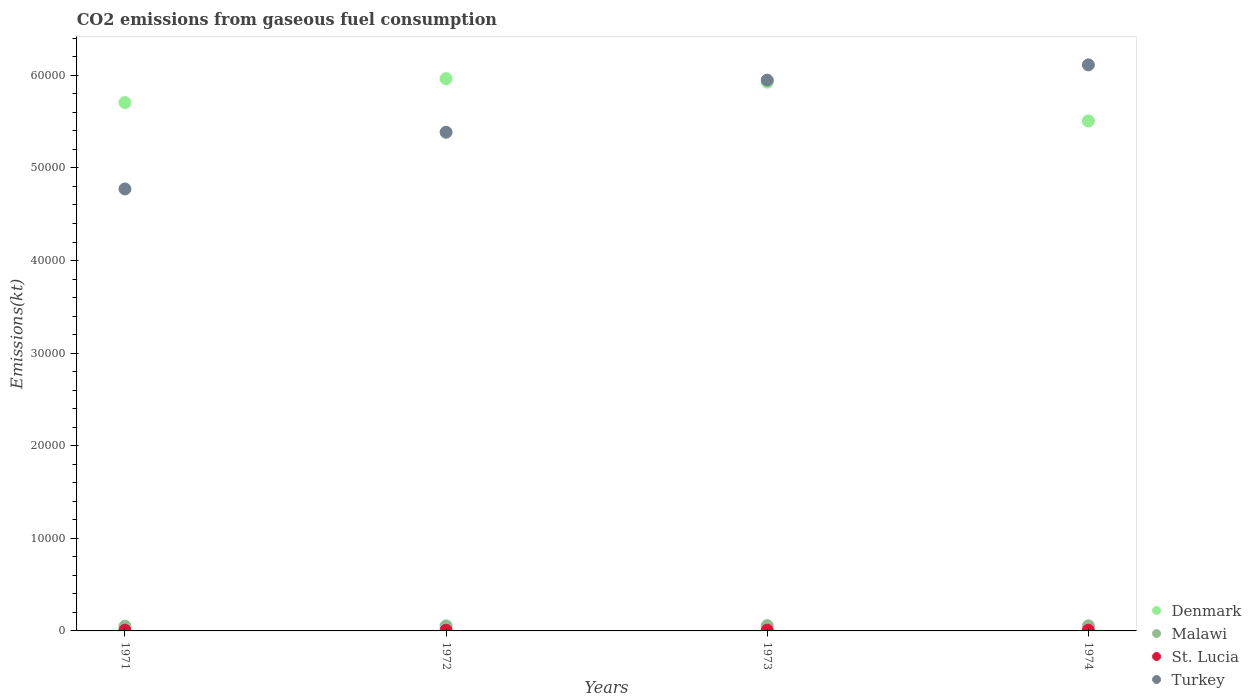What is the amount of CO2 emitted in Denmark in 1971?
Make the answer very short. 5.71e+04. Across all years, what is the maximum amount of CO2 emitted in Denmark?
Keep it short and to the point. 5.96e+04. Across all years, what is the minimum amount of CO2 emitted in Turkey?
Offer a terse response. 4.77e+04. In which year was the amount of CO2 emitted in St. Lucia maximum?
Keep it short and to the point. 1973. What is the total amount of CO2 emitted in Malawi in the graph?
Keep it short and to the point. 2170.86. What is the difference between the amount of CO2 emitted in Malawi in 1971 and that in 1974?
Provide a short and direct response. -47.67. What is the difference between the amount of CO2 emitted in Malawi in 1972 and the amount of CO2 emitted in Denmark in 1974?
Provide a short and direct response. -5.45e+04. What is the average amount of CO2 emitted in St. Lucia per year?
Your response must be concise. 75.17. In the year 1973, what is the difference between the amount of CO2 emitted in St. Lucia and amount of CO2 emitted in Malawi?
Give a very brief answer. -491.38. What is the ratio of the amount of CO2 emitted in Turkey in 1971 to that in 1974?
Ensure brevity in your answer.  0.78. What is the difference between the highest and the second highest amount of CO2 emitted in Denmark?
Offer a terse response. 377.7. What is the difference between the highest and the lowest amount of CO2 emitted in Malawi?
Your response must be concise. 69.67. In how many years, is the amount of CO2 emitted in Malawi greater than the average amount of CO2 emitted in Malawi taken over all years?
Offer a terse response. 3. Are the values on the major ticks of Y-axis written in scientific E-notation?
Provide a succinct answer. No. Does the graph contain grids?
Your answer should be compact. No. What is the title of the graph?
Give a very brief answer. CO2 emissions from gaseous fuel consumption. Does "Belize" appear as one of the legend labels in the graph?
Ensure brevity in your answer.  No. What is the label or title of the Y-axis?
Provide a short and direct response. Emissions(kt). What is the Emissions(kt) of Denmark in 1971?
Your answer should be compact. 5.71e+04. What is the Emissions(kt) of Malawi in 1971?
Provide a short and direct response. 502.38. What is the Emissions(kt) of St. Lucia in 1971?
Keep it short and to the point. 69.67. What is the Emissions(kt) of Turkey in 1971?
Your answer should be compact. 4.77e+04. What is the Emissions(kt) in Denmark in 1972?
Make the answer very short. 5.96e+04. What is the Emissions(kt) in Malawi in 1972?
Keep it short and to the point. 546.38. What is the Emissions(kt) in St. Lucia in 1972?
Your answer should be compact. 77.01. What is the Emissions(kt) in Turkey in 1972?
Make the answer very short. 5.39e+04. What is the Emissions(kt) in Denmark in 1973?
Provide a short and direct response. 5.93e+04. What is the Emissions(kt) of Malawi in 1973?
Offer a terse response. 572.05. What is the Emissions(kt) of St. Lucia in 1973?
Ensure brevity in your answer.  80.67. What is the Emissions(kt) in Turkey in 1973?
Provide a succinct answer. 5.95e+04. What is the Emissions(kt) of Denmark in 1974?
Ensure brevity in your answer.  5.51e+04. What is the Emissions(kt) in Malawi in 1974?
Provide a succinct answer. 550.05. What is the Emissions(kt) in St. Lucia in 1974?
Make the answer very short. 73.34. What is the Emissions(kt) of Turkey in 1974?
Provide a succinct answer. 6.11e+04. Across all years, what is the maximum Emissions(kt) of Denmark?
Provide a succinct answer. 5.96e+04. Across all years, what is the maximum Emissions(kt) in Malawi?
Your answer should be compact. 572.05. Across all years, what is the maximum Emissions(kt) of St. Lucia?
Offer a very short reply. 80.67. Across all years, what is the maximum Emissions(kt) of Turkey?
Keep it short and to the point. 6.11e+04. Across all years, what is the minimum Emissions(kt) of Denmark?
Ensure brevity in your answer.  5.51e+04. Across all years, what is the minimum Emissions(kt) in Malawi?
Your response must be concise. 502.38. Across all years, what is the minimum Emissions(kt) of St. Lucia?
Your response must be concise. 69.67. Across all years, what is the minimum Emissions(kt) of Turkey?
Provide a short and direct response. 4.77e+04. What is the total Emissions(kt) in Denmark in the graph?
Your answer should be compact. 2.31e+05. What is the total Emissions(kt) in Malawi in the graph?
Provide a short and direct response. 2170.86. What is the total Emissions(kt) of St. Lucia in the graph?
Provide a short and direct response. 300.69. What is the total Emissions(kt) of Turkey in the graph?
Offer a terse response. 2.22e+05. What is the difference between the Emissions(kt) of Denmark in 1971 and that in 1972?
Your response must be concise. -2581.57. What is the difference between the Emissions(kt) in Malawi in 1971 and that in 1972?
Your response must be concise. -44. What is the difference between the Emissions(kt) in St. Lucia in 1971 and that in 1972?
Your response must be concise. -7.33. What is the difference between the Emissions(kt) in Turkey in 1971 and that in 1972?
Offer a very short reply. -6123.89. What is the difference between the Emissions(kt) of Denmark in 1971 and that in 1973?
Provide a short and direct response. -2203.87. What is the difference between the Emissions(kt) of Malawi in 1971 and that in 1973?
Your answer should be compact. -69.67. What is the difference between the Emissions(kt) in St. Lucia in 1971 and that in 1973?
Your answer should be compact. -11. What is the difference between the Emissions(kt) of Turkey in 1971 and that in 1973?
Provide a succinct answer. -1.18e+04. What is the difference between the Emissions(kt) in Denmark in 1971 and that in 1974?
Your response must be concise. 1983.85. What is the difference between the Emissions(kt) in Malawi in 1971 and that in 1974?
Your answer should be compact. -47.67. What is the difference between the Emissions(kt) of St. Lucia in 1971 and that in 1974?
Keep it short and to the point. -3.67. What is the difference between the Emissions(kt) in Turkey in 1971 and that in 1974?
Provide a short and direct response. -1.34e+04. What is the difference between the Emissions(kt) in Denmark in 1972 and that in 1973?
Provide a short and direct response. 377.7. What is the difference between the Emissions(kt) in Malawi in 1972 and that in 1973?
Give a very brief answer. -25.67. What is the difference between the Emissions(kt) of St. Lucia in 1972 and that in 1973?
Ensure brevity in your answer.  -3.67. What is the difference between the Emissions(kt) in Turkey in 1972 and that in 1973?
Offer a very short reply. -5628.85. What is the difference between the Emissions(kt) of Denmark in 1972 and that in 1974?
Offer a very short reply. 4565.41. What is the difference between the Emissions(kt) of Malawi in 1972 and that in 1974?
Provide a succinct answer. -3.67. What is the difference between the Emissions(kt) of St. Lucia in 1972 and that in 1974?
Make the answer very short. 3.67. What is the difference between the Emissions(kt) of Turkey in 1972 and that in 1974?
Your answer should be very brief. -7278.99. What is the difference between the Emissions(kt) in Denmark in 1973 and that in 1974?
Offer a very short reply. 4187.71. What is the difference between the Emissions(kt) in Malawi in 1973 and that in 1974?
Your answer should be compact. 22. What is the difference between the Emissions(kt) of St. Lucia in 1973 and that in 1974?
Offer a very short reply. 7.33. What is the difference between the Emissions(kt) of Turkey in 1973 and that in 1974?
Keep it short and to the point. -1650.15. What is the difference between the Emissions(kt) of Denmark in 1971 and the Emissions(kt) of Malawi in 1972?
Keep it short and to the point. 5.65e+04. What is the difference between the Emissions(kt) in Denmark in 1971 and the Emissions(kt) in St. Lucia in 1972?
Provide a succinct answer. 5.70e+04. What is the difference between the Emissions(kt) of Denmark in 1971 and the Emissions(kt) of Turkey in 1972?
Offer a very short reply. 3204.96. What is the difference between the Emissions(kt) of Malawi in 1971 and the Emissions(kt) of St. Lucia in 1972?
Keep it short and to the point. 425.37. What is the difference between the Emissions(kt) of Malawi in 1971 and the Emissions(kt) of Turkey in 1972?
Offer a terse response. -5.34e+04. What is the difference between the Emissions(kt) of St. Lucia in 1971 and the Emissions(kt) of Turkey in 1972?
Your answer should be compact. -5.38e+04. What is the difference between the Emissions(kt) in Denmark in 1971 and the Emissions(kt) in Malawi in 1973?
Give a very brief answer. 5.65e+04. What is the difference between the Emissions(kt) of Denmark in 1971 and the Emissions(kt) of St. Lucia in 1973?
Make the answer very short. 5.70e+04. What is the difference between the Emissions(kt) in Denmark in 1971 and the Emissions(kt) in Turkey in 1973?
Your answer should be compact. -2423.89. What is the difference between the Emissions(kt) in Malawi in 1971 and the Emissions(kt) in St. Lucia in 1973?
Ensure brevity in your answer.  421.7. What is the difference between the Emissions(kt) in Malawi in 1971 and the Emissions(kt) in Turkey in 1973?
Your response must be concise. -5.90e+04. What is the difference between the Emissions(kt) in St. Lucia in 1971 and the Emissions(kt) in Turkey in 1973?
Keep it short and to the point. -5.94e+04. What is the difference between the Emissions(kt) of Denmark in 1971 and the Emissions(kt) of Malawi in 1974?
Provide a succinct answer. 5.65e+04. What is the difference between the Emissions(kt) of Denmark in 1971 and the Emissions(kt) of St. Lucia in 1974?
Provide a short and direct response. 5.70e+04. What is the difference between the Emissions(kt) of Denmark in 1971 and the Emissions(kt) of Turkey in 1974?
Ensure brevity in your answer.  -4074.04. What is the difference between the Emissions(kt) of Malawi in 1971 and the Emissions(kt) of St. Lucia in 1974?
Give a very brief answer. 429.04. What is the difference between the Emissions(kt) of Malawi in 1971 and the Emissions(kt) of Turkey in 1974?
Provide a succinct answer. -6.06e+04. What is the difference between the Emissions(kt) in St. Lucia in 1971 and the Emissions(kt) in Turkey in 1974?
Ensure brevity in your answer.  -6.11e+04. What is the difference between the Emissions(kt) of Denmark in 1972 and the Emissions(kt) of Malawi in 1973?
Provide a succinct answer. 5.91e+04. What is the difference between the Emissions(kt) of Denmark in 1972 and the Emissions(kt) of St. Lucia in 1973?
Your response must be concise. 5.96e+04. What is the difference between the Emissions(kt) of Denmark in 1972 and the Emissions(kt) of Turkey in 1973?
Your answer should be compact. 157.68. What is the difference between the Emissions(kt) of Malawi in 1972 and the Emissions(kt) of St. Lucia in 1973?
Provide a short and direct response. 465.71. What is the difference between the Emissions(kt) in Malawi in 1972 and the Emissions(kt) in Turkey in 1973?
Keep it short and to the point. -5.89e+04. What is the difference between the Emissions(kt) of St. Lucia in 1972 and the Emissions(kt) of Turkey in 1973?
Provide a short and direct response. -5.94e+04. What is the difference between the Emissions(kt) in Denmark in 1972 and the Emissions(kt) in Malawi in 1974?
Provide a short and direct response. 5.91e+04. What is the difference between the Emissions(kt) of Denmark in 1972 and the Emissions(kt) of St. Lucia in 1974?
Your response must be concise. 5.96e+04. What is the difference between the Emissions(kt) in Denmark in 1972 and the Emissions(kt) in Turkey in 1974?
Keep it short and to the point. -1492.47. What is the difference between the Emissions(kt) of Malawi in 1972 and the Emissions(kt) of St. Lucia in 1974?
Keep it short and to the point. 473.04. What is the difference between the Emissions(kt) in Malawi in 1972 and the Emissions(kt) in Turkey in 1974?
Ensure brevity in your answer.  -6.06e+04. What is the difference between the Emissions(kt) of St. Lucia in 1972 and the Emissions(kt) of Turkey in 1974?
Your response must be concise. -6.11e+04. What is the difference between the Emissions(kt) of Denmark in 1973 and the Emissions(kt) of Malawi in 1974?
Keep it short and to the point. 5.87e+04. What is the difference between the Emissions(kt) in Denmark in 1973 and the Emissions(kt) in St. Lucia in 1974?
Your answer should be very brief. 5.92e+04. What is the difference between the Emissions(kt) in Denmark in 1973 and the Emissions(kt) in Turkey in 1974?
Ensure brevity in your answer.  -1870.17. What is the difference between the Emissions(kt) in Malawi in 1973 and the Emissions(kt) in St. Lucia in 1974?
Give a very brief answer. 498.71. What is the difference between the Emissions(kt) in Malawi in 1973 and the Emissions(kt) in Turkey in 1974?
Make the answer very short. -6.06e+04. What is the difference between the Emissions(kt) in St. Lucia in 1973 and the Emissions(kt) in Turkey in 1974?
Provide a short and direct response. -6.11e+04. What is the average Emissions(kt) of Denmark per year?
Offer a very short reply. 5.78e+04. What is the average Emissions(kt) of Malawi per year?
Your answer should be compact. 542.72. What is the average Emissions(kt) of St. Lucia per year?
Provide a succinct answer. 75.17. What is the average Emissions(kt) in Turkey per year?
Your answer should be compact. 5.56e+04. In the year 1971, what is the difference between the Emissions(kt) of Denmark and Emissions(kt) of Malawi?
Provide a short and direct response. 5.66e+04. In the year 1971, what is the difference between the Emissions(kt) of Denmark and Emissions(kt) of St. Lucia?
Make the answer very short. 5.70e+04. In the year 1971, what is the difference between the Emissions(kt) of Denmark and Emissions(kt) of Turkey?
Give a very brief answer. 9328.85. In the year 1971, what is the difference between the Emissions(kt) in Malawi and Emissions(kt) in St. Lucia?
Keep it short and to the point. 432.71. In the year 1971, what is the difference between the Emissions(kt) in Malawi and Emissions(kt) in Turkey?
Provide a short and direct response. -4.72e+04. In the year 1971, what is the difference between the Emissions(kt) in St. Lucia and Emissions(kt) in Turkey?
Ensure brevity in your answer.  -4.77e+04. In the year 1972, what is the difference between the Emissions(kt) in Denmark and Emissions(kt) in Malawi?
Provide a succinct answer. 5.91e+04. In the year 1972, what is the difference between the Emissions(kt) of Denmark and Emissions(kt) of St. Lucia?
Make the answer very short. 5.96e+04. In the year 1972, what is the difference between the Emissions(kt) of Denmark and Emissions(kt) of Turkey?
Make the answer very short. 5786.53. In the year 1972, what is the difference between the Emissions(kt) of Malawi and Emissions(kt) of St. Lucia?
Provide a succinct answer. 469.38. In the year 1972, what is the difference between the Emissions(kt) in Malawi and Emissions(kt) in Turkey?
Make the answer very short. -5.33e+04. In the year 1972, what is the difference between the Emissions(kt) of St. Lucia and Emissions(kt) of Turkey?
Keep it short and to the point. -5.38e+04. In the year 1973, what is the difference between the Emissions(kt) of Denmark and Emissions(kt) of Malawi?
Ensure brevity in your answer.  5.87e+04. In the year 1973, what is the difference between the Emissions(kt) of Denmark and Emissions(kt) of St. Lucia?
Provide a short and direct response. 5.92e+04. In the year 1973, what is the difference between the Emissions(kt) of Denmark and Emissions(kt) of Turkey?
Give a very brief answer. -220.02. In the year 1973, what is the difference between the Emissions(kt) in Malawi and Emissions(kt) in St. Lucia?
Offer a terse response. 491.38. In the year 1973, what is the difference between the Emissions(kt) of Malawi and Emissions(kt) of Turkey?
Keep it short and to the point. -5.89e+04. In the year 1973, what is the difference between the Emissions(kt) in St. Lucia and Emissions(kt) in Turkey?
Your answer should be compact. -5.94e+04. In the year 1974, what is the difference between the Emissions(kt) of Denmark and Emissions(kt) of Malawi?
Your answer should be very brief. 5.45e+04. In the year 1974, what is the difference between the Emissions(kt) of Denmark and Emissions(kt) of St. Lucia?
Your answer should be compact. 5.50e+04. In the year 1974, what is the difference between the Emissions(kt) of Denmark and Emissions(kt) of Turkey?
Your answer should be compact. -6057.88. In the year 1974, what is the difference between the Emissions(kt) in Malawi and Emissions(kt) in St. Lucia?
Ensure brevity in your answer.  476.71. In the year 1974, what is the difference between the Emissions(kt) of Malawi and Emissions(kt) of Turkey?
Offer a terse response. -6.06e+04. In the year 1974, what is the difference between the Emissions(kt) in St. Lucia and Emissions(kt) in Turkey?
Provide a short and direct response. -6.11e+04. What is the ratio of the Emissions(kt) in Denmark in 1971 to that in 1972?
Provide a short and direct response. 0.96. What is the ratio of the Emissions(kt) of Malawi in 1971 to that in 1972?
Make the answer very short. 0.92. What is the ratio of the Emissions(kt) of St. Lucia in 1971 to that in 1972?
Your response must be concise. 0.9. What is the ratio of the Emissions(kt) in Turkey in 1971 to that in 1972?
Your answer should be very brief. 0.89. What is the ratio of the Emissions(kt) of Denmark in 1971 to that in 1973?
Provide a short and direct response. 0.96. What is the ratio of the Emissions(kt) of Malawi in 1971 to that in 1973?
Give a very brief answer. 0.88. What is the ratio of the Emissions(kt) of St. Lucia in 1971 to that in 1973?
Provide a succinct answer. 0.86. What is the ratio of the Emissions(kt) of Turkey in 1971 to that in 1973?
Provide a succinct answer. 0.8. What is the ratio of the Emissions(kt) in Denmark in 1971 to that in 1974?
Your answer should be very brief. 1.04. What is the ratio of the Emissions(kt) of Malawi in 1971 to that in 1974?
Offer a very short reply. 0.91. What is the ratio of the Emissions(kt) in St. Lucia in 1971 to that in 1974?
Your answer should be compact. 0.95. What is the ratio of the Emissions(kt) of Turkey in 1971 to that in 1974?
Give a very brief answer. 0.78. What is the ratio of the Emissions(kt) of Denmark in 1972 to that in 1973?
Give a very brief answer. 1.01. What is the ratio of the Emissions(kt) in Malawi in 1972 to that in 1973?
Provide a succinct answer. 0.96. What is the ratio of the Emissions(kt) of St. Lucia in 1972 to that in 1973?
Your response must be concise. 0.95. What is the ratio of the Emissions(kt) in Turkey in 1972 to that in 1973?
Give a very brief answer. 0.91. What is the ratio of the Emissions(kt) of Denmark in 1972 to that in 1974?
Provide a short and direct response. 1.08. What is the ratio of the Emissions(kt) of St. Lucia in 1972 to that in 1974?
Ensure brevity in your answer.  1.05. What is the ratio of the Emissions(kt) of Turkey in 1972 to that in 1974?
Keep it short and to the point. 0.88. What is the ratio of the Emissions(kt) of Denmark in 1973 to that in 1974?
Make the answer very short. 1.08. What is the difference between the highest and the second highest Emissions(kt) of Denmark?
Provide a succinct answer. 377.7. What is the difference between the highest and the second highest Emissions(kt) in Malawi?
Your answer should be very brief. 22. What is the difference between the highest and the second highest Emissions(kt) of St. Lucia?
Your response must be concise. 3.67. What is the difference between the highest and the second highest Emissions(kt) in Turkey?
Your answer should be compact. 1650.15. What is the difference between the highest and the lowest Emissions(kt) in Denmark?
Keep it short and to the point. 4565.41. What is the difference between the highest and the lowest Emissions(kt) of Malawi?
Offer a very short reply. 69.67. What is the difference between the highest and the lowest Emissions(kt) of St. Lucia?
Keep it short and to the point. 11. What is the difference between the highest and the lowest Emissions(kt) in Turkey?
Your answer should be very brief. 1.34e+04. 